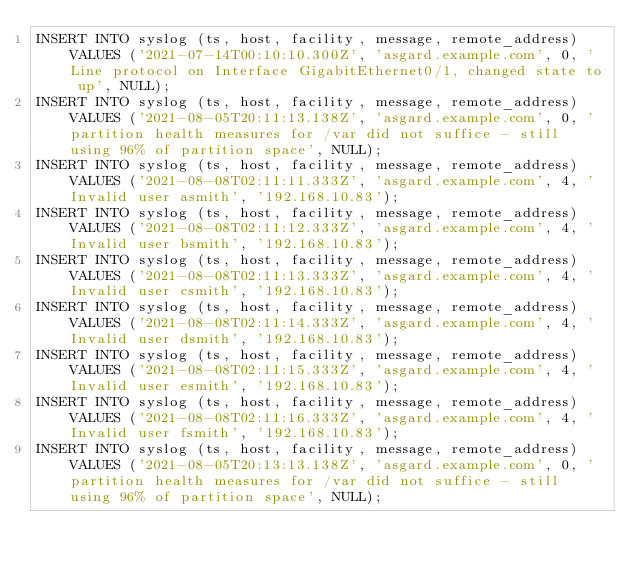<code> <loc_0><loc_0><loc_500><loc_500><_SQL_>INSERT INTO syslog (ts, host, facility, message, remote_address) VALUES ('2021-07-14T00:10:10.300Z', 'asgard.example.com', 0, 'Line protocol on Interface GigabitEthernet0/1, changed state to up', NULL);
INSERT INTO syslog (ts, host, facility, message, remote_address) VALUES ('2021-08-05T20:11:13.138Z', 'asgard.example.com', 0, 'partition health measures for /var did not suffice - still using 96% of partition space', NULL);
INSERT INTO syslog (ts, host, facility, message, remote_address) VALUES ('2021-08-08T02:11:11.333Z', 'asgard.example.com', 4, 'Invalid user asmith', '192.168.10.83');
INSERT INTO syslog (ts, host, facility, message, remote_address) VALUES ('2021-08-08T02:11:12.333Z', 'asgard.example.com', 4, 'Invalid user bsmith', '192.168.10.83');
INSERT INTO syslog (ts, host, facility, message, remote_address) VALUES ('2021-08-08T02:11:13.333Z', 'asgard.example.com', 4, 'Invalid user csmith', '192.168.10.83');
INSERT INTO syslog (ts, host, facility, message, remote_address) VALUES ('2021-08-08T02:11:14.333Z', 'asgard.example.com', 4, 'Invalid user dsmith', '192.168.10.83');
INSERT INTO syslog (ts, host, facility, message, remote_address) VALUES ('2021-08-08T02:11:15.333Z', 'asgard.example.com', 4, 'Invalid user esmith', '192.168.10.83');
INSERT INTO syslog (ts, host, facility, message, remote_address) VALUES ('2021-08-08T02:11:16.333Z', 'asgard.example.com', 4, 'Invalid user fsmith', '192.168.10.83');
INSERT INTO syslog (ts, host, facility, message, remote_address) VALUES ('2021-08-05T20:13:13.138Z', 'asgard.example.com', 0, 'partition health measures for /var did not suffice - still using 96% of partition space', NULL);
</code> 